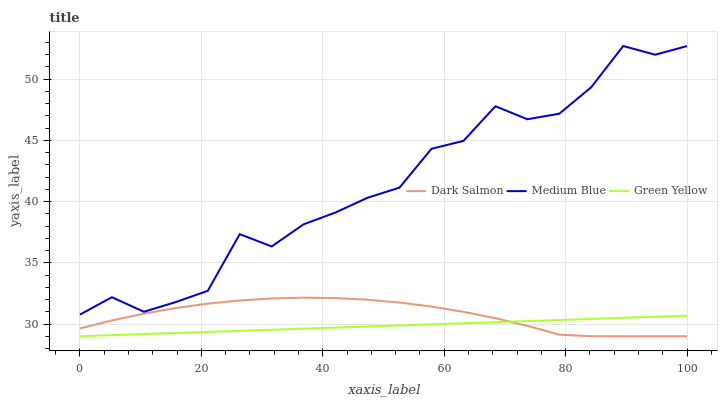Does Dark Salmon have the minimum area under the curve?
Answer yes or no. No. Does Dark Salmon have the maximum area under the curve?
Answer yes or no. No. Is Dark Salmon the smoothest?
Answer yes or no. No. Is Dark Salmon the roughest?
Answer yes or no. No. Does Medium Blue have the lowest value?
Answer yes or no. No. Does Dark Salmon have the highest value?
Answer yes or no. No. Is Green Yellow less than Medium Blue?
Answer yes or no. Yes. Is Medium Blue greater than Dark Salmon?
Answer yes or no. Yes. Does Green Yellow intersect Medium Blue?
Answer yes or no. No. 